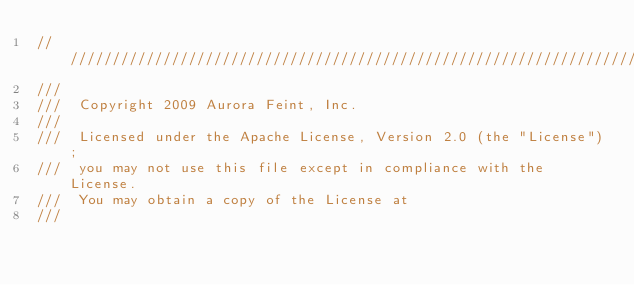Convert code to text. <code><loc_0><loc_0><loc_500><loc_500><_ObjectiveC_>////////////////////////////////////////////////////////////////////////////////////////////////////////////////////////
/// 
///  Copyright 2009 Aurora Feint, Inc.
/// 
///  Licensed under the Apache License, Version 2.0 (the "License");
///  you may not use this file except in compliance with the License.
///  You may obtain a copy of the License at
///  </code> 